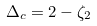Convert formula to latex. <formula><loc_0><loc_0><loc_500><loc_500>\Delta _ { c } = 2 - \zeta _ { 2 }</formula> 